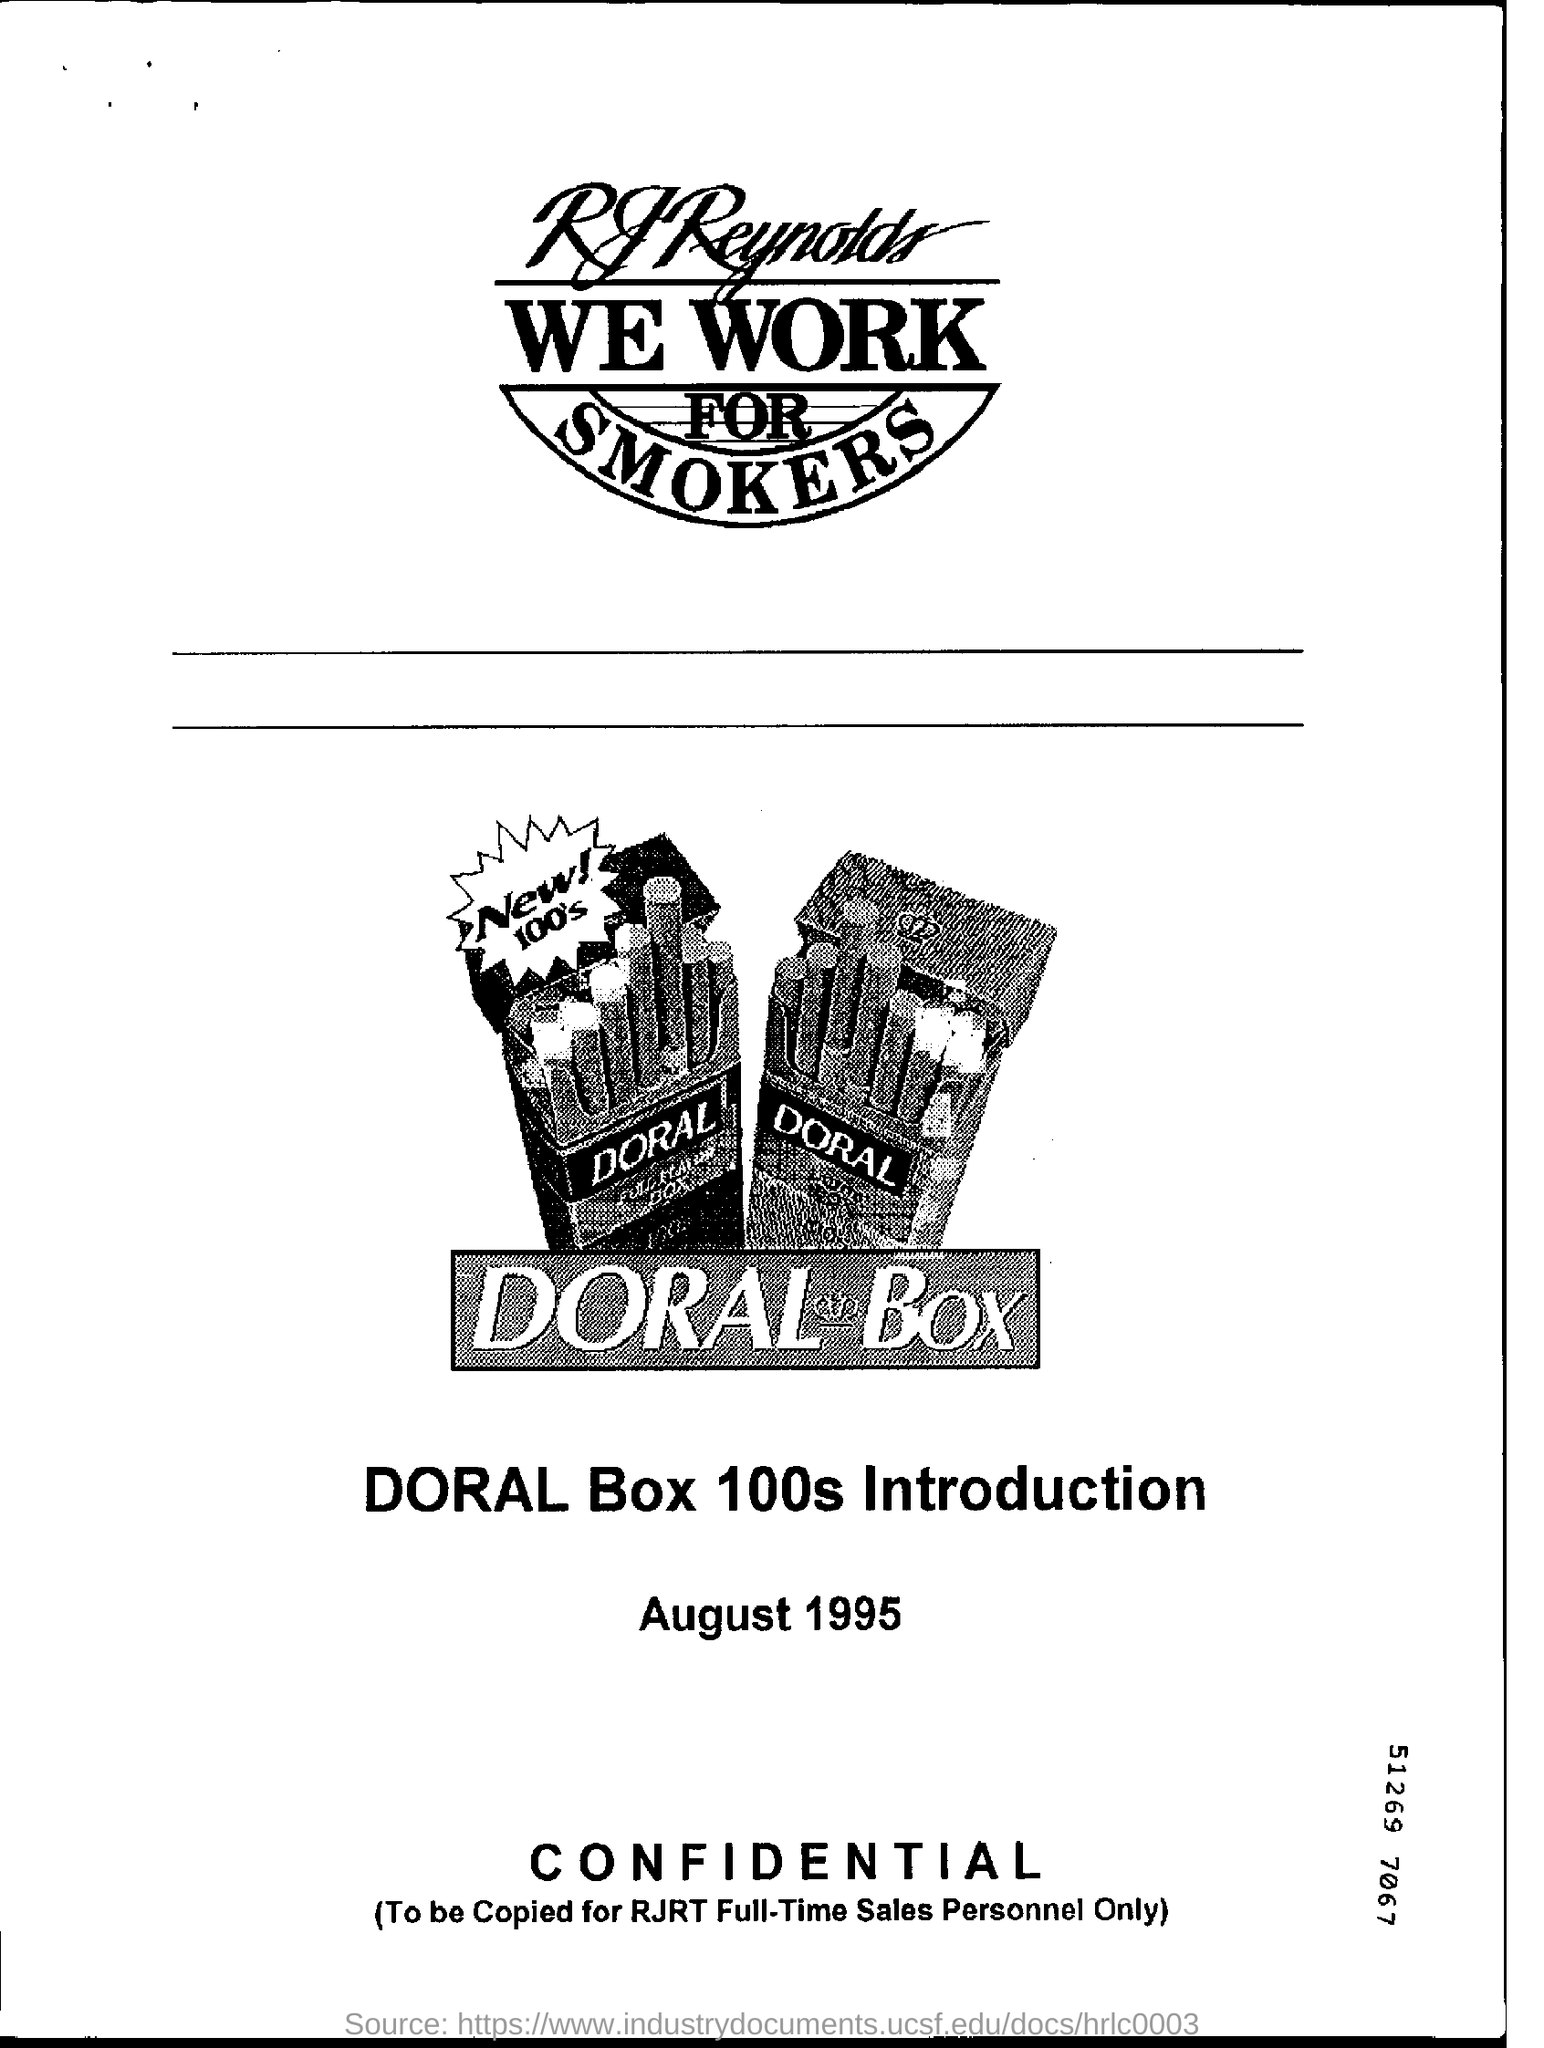Which brand is going to be introduced?
Offer a terse response. DORAL Box 100s. 